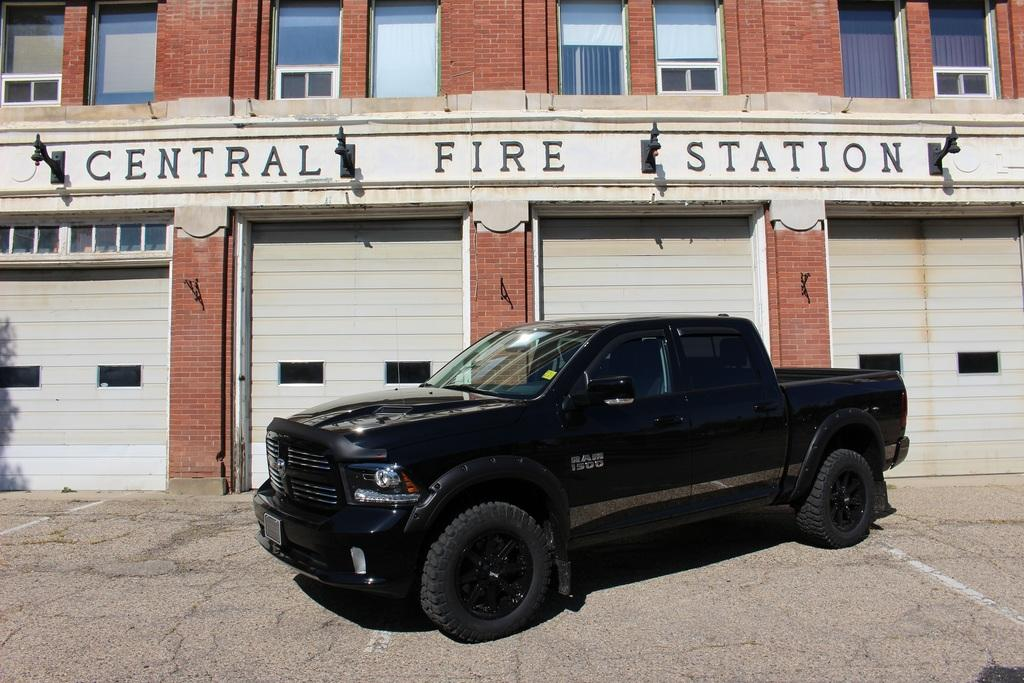What is the main subject in the middle of the image? There is a car in the middle of the image. What can be seen behind the car? There is a building behind the car. Is there any text visible in the image? Yes, there is some text visible in the image. How many toys are scattered around the car in the image? There are no toys present in the image. What is the crowd doing in the image? There is no crowd present in the image. 